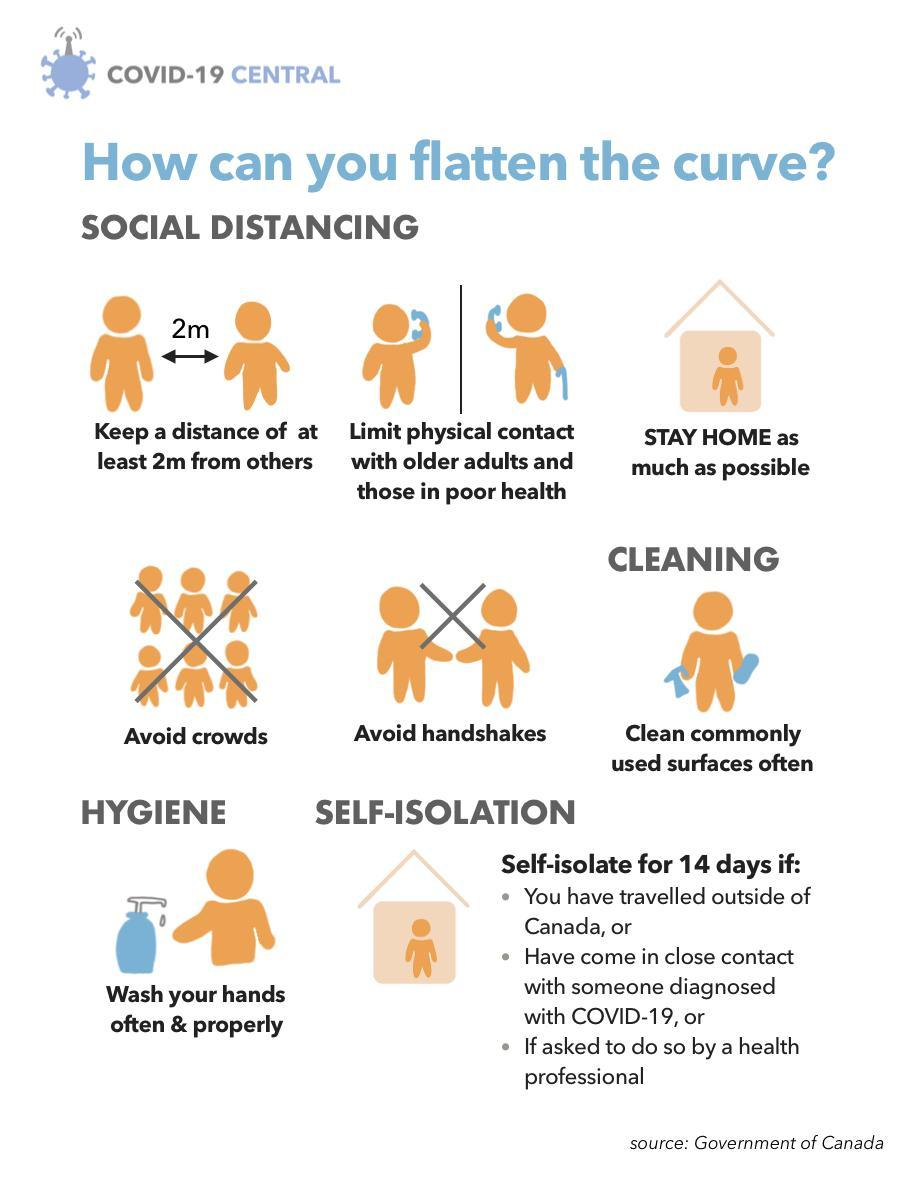What are the two things to be avoided in order to control the spread of COVID-19 virus?
Answer the question with a short phrase. crowds, handshakes How many reasons have been highlighted to self-isolate 3 What is the minimum safe distance to be maintained between yourself & others inorder to control the spread of COVID-19 virus? at least 2m How many don'ts are mentioned in this infographic image? 2 